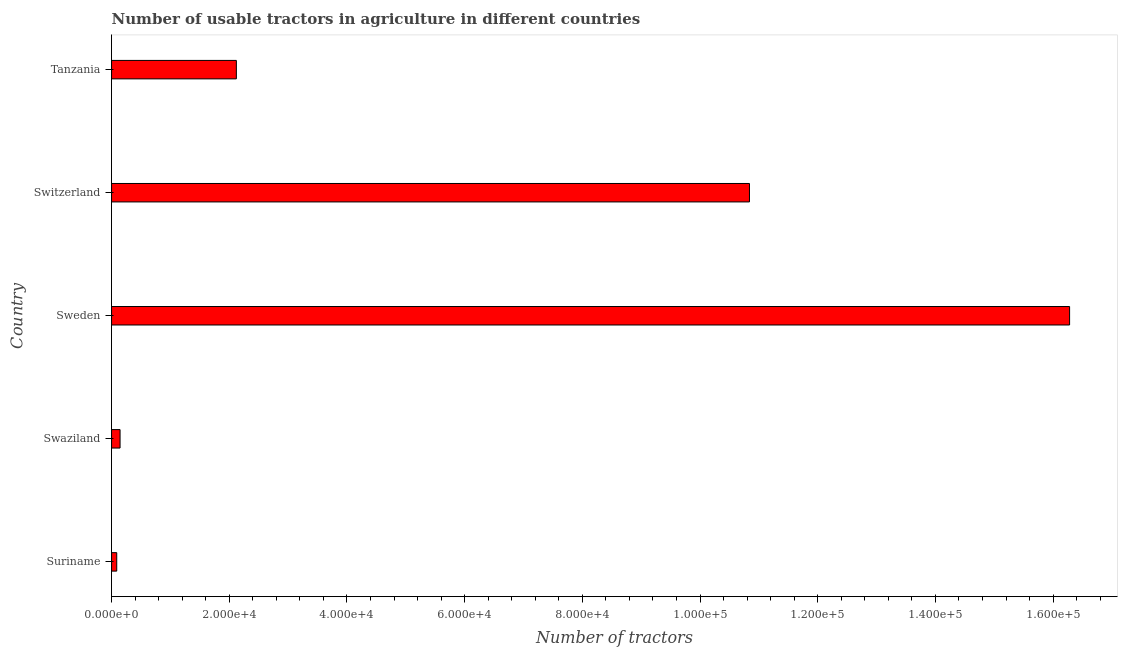Does the graph contain grids?
Provide a succinct answer. No. What is the title of the graph?
Your answer should be very brief. Number of usable tractors in agriculture in different countries. What is the label or title of the X-axis?
Give a very brief answer. Number of tractors. What is the number of tractors in Swaziland?
Ensure brevity in your answer.  1445. Across all countries, what is the maximum number of tractors?
Your answer should be compact. 1.63e+05. Across all countries, what is the minimum number of tractors?
Keep it short and to the point. 880. In which country was the number of tractors minimum?
Your answer should be compact. Suriname. What is the sum of the number of tractors?
Provide a short and direct response. 2.95e+05. What is the difference between the number of tractors in Suriname and Switzerland?
Your answer should be compact. -1.08e+05. What is the average number of tractors per country?
Make the answer very short. 5.89e+04. What is the median number of tractors?
Offer a very short reply. 2.12e+04. In how many countries, is the number of tractors greater than 60000 ?
Give a very brief answer. 2. What is the ratio of the number of tractors in Sweden to that in Switzerland?
Provide a succinct answer. 1.5. What is the difference between the highest and the second highest number of tractors?
Keep it short and to the point. 5.44e+04. What is the difference between the highest and the lowest number of tractors?
Your response must be concise. 1.62e+05. Are the values on the major ticks of X-axis written in scientific E-notation?
Your answer should be compact. Yes. What is the Number of tractors in Suriname?
Your answer should be compact. 880. What is the Number of tractors in Swaziland?
Ensure brevity in your answer.  1445. What is the Number of tractors in Sweden?
Make the answer very short. 1.63e+05. What is the Number of tractors of Switzerland?
Keep it short and to the point. 1.08e+05. What is the Number of tractors in Tanzania?
Offer a terse response. 2.12e+04. What is the difference between the Number of tractors in Suriname and Swaziland?
Make the answer very short. -565. What is the difference between the Number of tractors in Suriname and Sweden?
Your answer should be compact. -1.62e+05. What is the difference between the Number of tractors in Suriname and Switzerland?
Ensure brevity in your answer.  -1.08e+05. What is the difference between the Number of tractors in Suriname and Tanzania?
Your answer should be very brief. -2.03e+04. What is the difference between the Number of tractors in Swaziland and Sweden?
Offer a terse response. -1.61e+05. What is the difference between the Number of tractors in Swaziland and Switzerland?
Provide a succinct answer. -1.07e+05. What is the difference between the Number of tractors in Swaziland and Tanzania?
Offer a terse response. -1.98e+04. What is the difference between the Number of tractors in Sweden and Switzerland?
Give a very brief answer. 5.44e+04. What is the difference between the Number of tractors in Sweden and Tanzania?
Give a very brief answer. 1.42e+05. What is the difference between the Number of tractors in Switzerland and Tanzania?
Make the answer very short. 8.72e+04. What is the ratio of the Number of tractors in Suriname to that in Swaziland?
Your response must be concise. 0.61. What is the ratio of the Number of tractors in Suriname to that in Sweden?
Your answer should be very brief. 0.01. What is the ratio of the Number of tractors in Suriname to that in Switzerland?
Ensure brevity in your answer.  0.01. What is the ratio of the Number of tractors in Suriname to that in Tanzania?
Your response must be concise. 0.04. What is the ratio of the Number of tractors in Swaziland to that in Sweden?
Offer a terse response. 0.01. What is the ratio of the Number of tractors in Swaziland to that in Switzerland?
Provide a succinct answer. 0.01. What is the ratio of the Number of tractors in Swaziland to that in Tanzania?
Make the answer very short. 0.07. What is the ratio of the Number of tractors in Sweden to that in Switzerland?
Offer a very short reply. 1.5. What is the ratio of the Number of tractors in Sweden to that in Tanzania?
Provide a short and direct response. 7.68. What is the ratio of the Number of tractors in Switzerland to that in Tanzania?
Give a very brief answer. 5.11. 